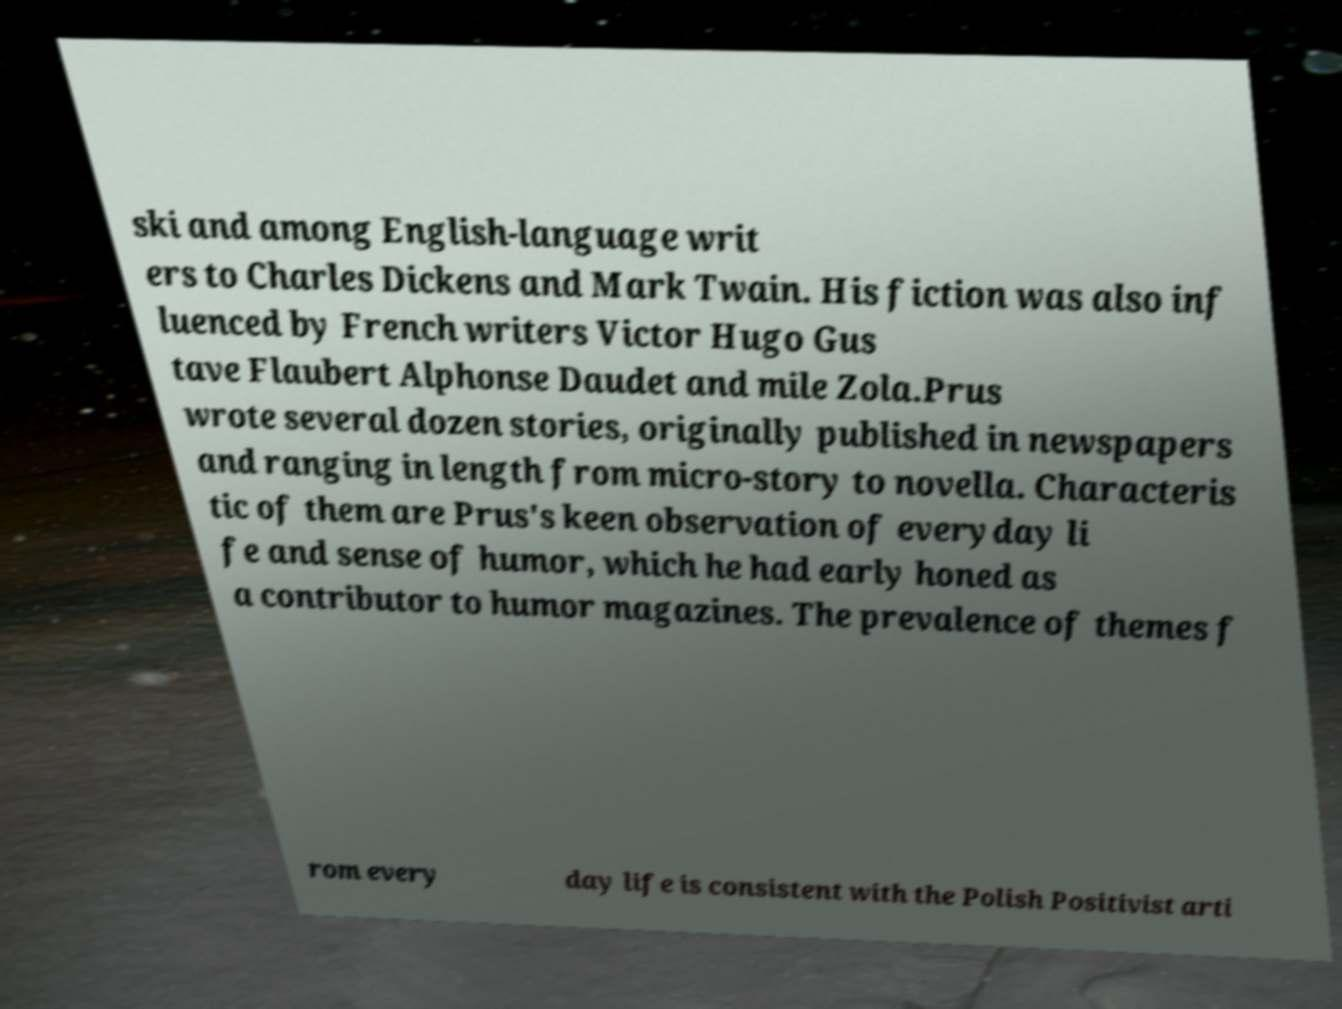Please read and relay the text visible in this image. What does it say? ski and among English-language writ ers to Charles Dickens and Mark Twain. His fiction was also inf luenced by French writers Victor Hugo Gus tave Flaubert Alphonse Daudet and mile Zola.Prus wrote several dozen stories, originally published in newspapers and ranging in length from micro-story to novella. Characteris tic of them are Prus's keen observation of everyday li fe and sense of humor, which he had early honed as a contributor to humor magazines. The prevalence of themes f rom every day life is consistent with the Polish Positivist arti 